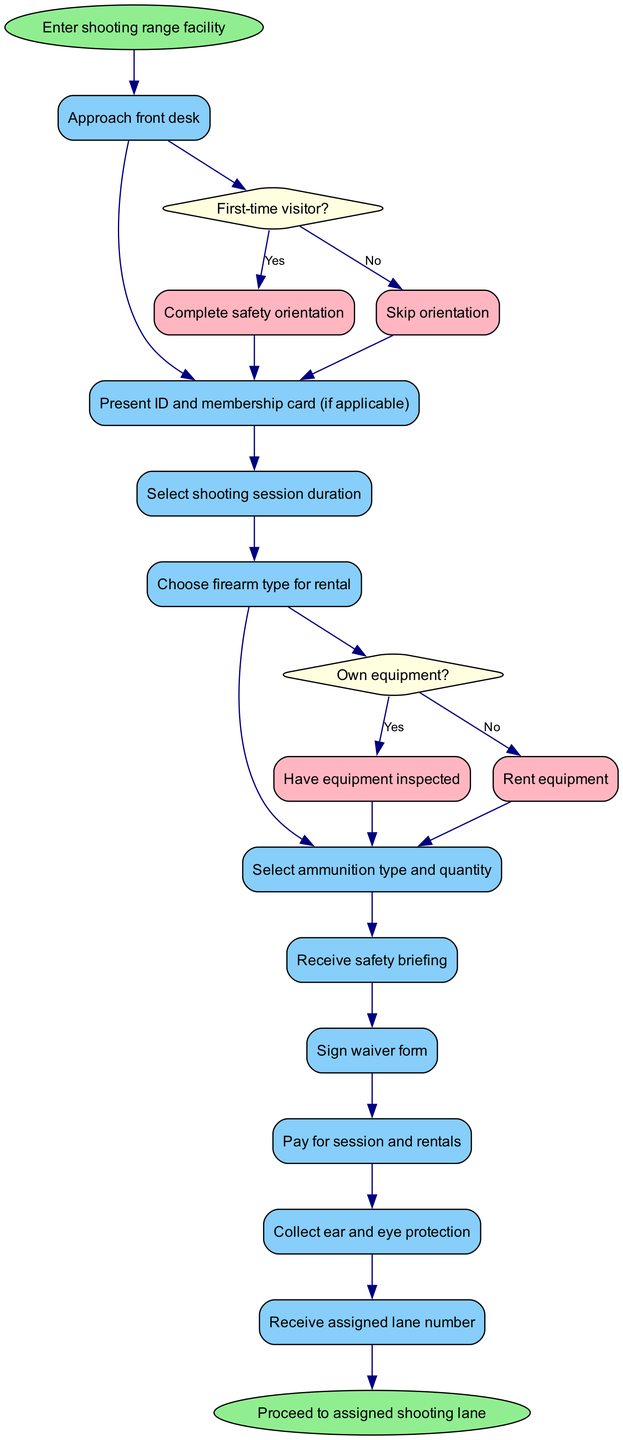What is the first activity in the diagram? The first activity in the diagram is connected to the start node. The start node leads directly to "Approach front desk," which is the first activity.
Answer: Approach front desk How many activities are there in total? By counting each activity listed in the diagram, we find there are 10 activities performed before reaching the end node.
Answer: 10 What happens if someone is a first-time visitor? A first-time visitor will be directed to "Complete safety orientation" after making their selection at the front desk. This follows the decision node specifically for first-time visitors.
Answer: Complete safety orientation What does a person do after paying for the session and rentals? After paying for the session and rentals, the next step in the process is "Collect ear and eye protection." This shows the sequential flow of activities following the payment.
Answer: Collect ear and eye protection What are the two options presented after deciding if the visitor owns equipment? The decision node regarding whether the visitor owns equipment presents two options: if the answer is "Yes," they will "Have equipment inspected," and if "No," they will "Rent equipment." These are the branches stemming from that decision.
Answer: Have equipment inspected, Rent equipment How does the process end? The process ends after the last activity, which is reached following "Receive assigned lane number." This directly connects to the end node, "Proceed to assigned shooting lane."
Answer: Proceed to assigned shooting lane What shape represents the decision nodes in the diagram? The decision nodes are represented as diamonds in the diagram, which is a common shape used to indicate choices or decisions in activity diagrams.
Answer: Diamond What should someone do if they choose not to rent equipment? If someone decides they do not want to rent equipment, they must follow the path to "Have equipment inspected," which is the action taken if they own equipment.
Answer: Have equipment inspected 